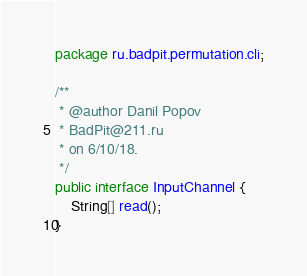<code> <loc_0><loc_0><loc_500><loc_500><_Java_>package ru.badpit.permutation.cli;

/**
 * @author Danil Popov
 * BadPit@211.ru
 * on 6/10/18.
 */
public interface InputChannel {
    String[] read();
}
</code> 